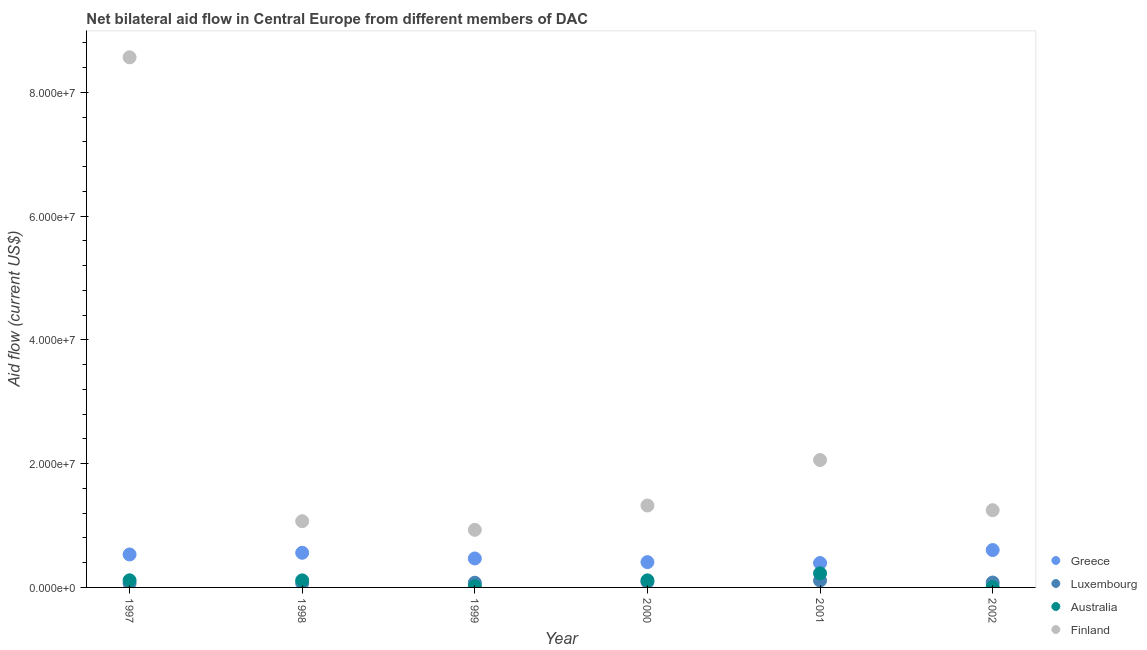How many different coloured dotlines are there?
Ensure brevity in your answer.  4. What is the amount of aid given by finland in 1999?
Make the answer very short. 9.31e+06. Across all years, what is the maximum amount of aid given by finland?
Make the answer very short. 8.57e+07. Across all years, what is the minimum amount of aid given by luxembourg?
Offer a very short reply. 6.50e+05. In which year was the amount of aid given by australia minimum?
Offer a terse response. 2002. What is the total amount of aid given by australia in the graph?
Your answer should be very brief. 5.96e+06. What is the difference between the amount of aid given by luxembourg in 2001 and that in 2002?
Your response must be concise. 3.20e+05. What is the difference between the amount of aid given by greece in 1998 and the amount of aid given by luxembourg in 2000?
Give a very brief answer. 4.72e+06. What is the average amount of aid given by australia per year?
Ensure brevity in your answer.  9.93e+05. In the year 1998, what is the difference between the amount of aid given by finland and amount of aid given by greece?
Give a very brief answer. 5.10e+06. In how many years, is the amount of aid given by australia greater than 24000000 US$?
Offer a terse response. 0. What is the ratio of the amount of aid given by greece in 2000 to that in 2001?
Ensure brevity in your answer.  1.04. What is the difference between the highest and the second highest amount of aid given by luxembourg?
Provide a succinct answer. 2.30e+05. What is the difference between the highest and the lowest amount of aid given by australia?
Offer a very short reply. 2.23e+06. In how many years, is the amount of aid given by greece greater than the average amount of aid given by greece taken over all years?
Ensure brevity in your answer.  3. Is it the case that in every year, the sum of the amount of aid given by luxembourg and amount of aid given by australia is greater than the sum of amount of aid given by greece and amount of aid given by finland?
Ensure brevity in your answer.  No. Does the amount of aid given by luxembourg monotonically increase over the years?
Offer a terse response. No. Is the amount of aid given by finland strictly greater than the amount of aid given by luxembourg over the years?
Provide a short and direct response. Yes. Is the amount of aid given by greece strictly less than the amount of aid given by luxembourg over the years?
Keep it short and to the point. No. How many dotlines are there?
Provide a short and direct response. 4. How many years are there in the graph?
Make the answer very short. 6. Are the values on the major ticks of Y-axis written in scientific E-notation?
Make the answer very short. Yes. Does the graph contain grids?
Provide a succinct answer. No. Where does the legend appear in the graph?
Offer a very short reply. Bottom right. How many legend labels are there?
Your answer should be very brief. 4. How are the legend labels stacked?
Make the answer very short. Vertical. What is the title of the graph?
Give a very brief answer. Net bilateral aid flow in Central Europe from different members of DAC. Does "Payroll services" appear as one of the legend labels in the graph?
Your answer should be very brief. No. What is the Aid flow (current US$) in Greece in 1997?
Offer a very short reply. 5.33e+06. What is the Aid flow (current US$) in Luxembourg in 1997?
Provide a short and direct response. 6.50e+05. What is the Aid flow (current US$) of Australia in 1997?
Provide a short and direct response. 1.15e+06. What is the Aid flow (current US$) of Finland in 1997?
Provide a short and direct response. 8.57e+07. What is the Aid flow (current US$) in Greece in 1998?
Ensure brevity in your answer.  5.60e+06. What is the Aid flow (current US$) of Luxembourg in 1998?
Keep it short and to the point. 6.90e+05. What is the Aid flow (current US$) in Australia in 1998?
Offer a terse response. 1.14e+06. What is the Aid flow (current US$) in Finland in 1998?
Ensure brevity in your answer.  1.07e+07. What is the Aid flow (current US$) in Greece in 1999?
Your answer should be very brief. 4.68e+06. What is the Aid flow (current US$) of Luxembourg in 1999?
Your answer should be very brief. 7.60e+05. What is the Aid flow (current US$) of Australia in 1999?
Give a very brief answer. 2.00e+05. What is the Aid flow (current US$) in Finland in 1999?
Your answer should be compact. 9.31e+06. What is the Aid flow (current US$) of Greece in 2000?
Keep it short and to the point. 4.09e+06. What is the Aid flow (current US$) of Luxembourg in 2000?
Your response must be concise. 8.80e+05. What is the Aid flow (current US$) of Australia in 2000?
Your answer should be compact. 1.14e+06. What is the Aid flow (current US$) in Finland in 2000?
Keep it short and to the point. 1.32e+07. What is the Aid flow (current US$) of Greece in 2001?
Give a very brief answer. 3.94e+06. What is the Aid flow (current US$) in Luxembourg in 2001?
Your response must be concise. 1.11e+06. What is the Aid flow (current US$) of Australia in 2001?
Make the answer very short. 2.28e+06. What is the Aid flow (current US$) of Finland in 2001?
Offer a terse response. 2.06e+07. What is the Aid flow (current US$) of Greece in 2002?
Your answer should be compact. 6.04e+06. What is the Aid flow (current US$) in Luxembourg in 2002?
Provide a succinct answer. 7.90e+05. What is the Aid flow (current US$) in Finland in 2002?
Provide a succinct answer. 1.25e+07. Across all years, what is the maximum Aid flow (current US$) in Greece?
Your answer should be compact. 6.04e+06. Across all years, what is the maximum Aid flow (current US$) in Luxembourg?
Your answer should be very brief. 1.11e+06. Across all years, what is the maximum Aid flow (current US$) in Australia?
Offer a very short reply. 2.28e+06. Across all years, what is the maximum Aid flow (current US$) of Finland?
Your answer should be compact. 8.57e+07. Across all years, what is the minimum Aid flow (current US$) in Greece?
Offer a very short reply. 3.94e+06. Across all years, what is the minimum Aid flow (current US$) of Luxembourg?
Offer a terse response. 6.50e+05. Across all years, what is the minimum Aid flow (current US$) in Finland?
Ensure brevity in your answer.  9.31e+06. What is the total Aid flow (current US$) of Greece in the graph?
Offer a very short reply. 2.97e+07. What is the total Aid flow (current US$) in Luxembourg in the graph?
Your response must be concise. 4.88e+06. What is the total Aid flow (current US$) in Australia in the graph?
Provide a succinct answer. 5.96e+06. What is the total Aid flow (current US$) of Finland in the graph?
Your answer should be compact. 1.52e+08. What is the difference between the Aid flow (current US$) in Greece in 1997 and that in 1998?
Offer a terse response. -2.70e+05. What is the difference between the Aid flow (current US$) of Finland in 1997 and that in 1998?
Ensure brevity in your answer.  7.50e+07. What is the difference between the Aid flow (current US$) of Greece in 1997 and that in 1999?
Your answer should be compact. 6.50e+05. What is the difference between the Aid flow (current US$) of Australia in 1997 and that in 1999?
Make the answer very short. 9.50e+05. What is the difference between the Aid flow (current US$) of Finland in 1997 and that in 1999?
Provide a succinct answer. 7.64e+07. What is the difference between the Aid flow (current US$) of Greece in 1997 and that in 2000?
Your answer should be compact. 1.24e+06. What is the difference between the Aid flow (current US$) in Luxembourg in 1997 and that in 2000?
Ensure brevity in your answer.  -2.30e+05. What is the difference between the Aid flow (current US$) of Australia in 1997 and that in 2000?
Provide a succinct answer. 10000. What is the difference between the Aid flow (current US$) in Finland in 1997 and that in 2000?
Offer a terse response. 7.24e+07. What is the difference between the Aid flow (current US$) of Greece in 1997 and that in 2001?
Keep it short and to the point. 1.39e+06. What is the difference between the Aid flow (current US$) of Luxembourg in 1997 and that in 2001?
Your answer should be compact. -4.60e+05. What is the difference between the Aid flow (current US$) of Australia in 1997 and that in 2001?
Give a very brief answer. -1.13e+06. What is the difference between the Aid flow (current US$) of Finland in 1997 and that in 2001?
Give a very brief answer. 6.51e+07. What is the difference between the Aid flow (current US$) of Greece in 1997 and that in 2002?
Give a very brief answer. -7.10e+05. What is the difference between the Aid flow (current US$) of Australia in 1997 and that in 2002?
Ensure brevity in your answer.  1.10e+06. What is the difference between the Aid flow (current US$) of Finland in 1997 and that in 2002?
Your answer should be compact. 7.32e+07. What is the difference between the Aid flow (current US$) of Greece in 1998 and that in 1999?
Your response must be concise. 9.20e+05. What is the difference between the Aid flow (current US$) of Luxembourg in 1998 and that in 1999?
Your answer should be very brief. -7.00e+04. What is the difference between the Aid flow (current US$) in Australia in 1998 and that in 1999?
Offer a terse response. 9.40e+05. What is the difference between the Aid flow (current US$) in Finland in 1998 and that in 1999?
Make the answer very short. 1.39e+06. What is the difference between the Aid flow (current US$) in Greece in 1998 and that in 2000?
Offer a very short reply. 1.51e+06. What is the difference between the Aid flow (current US$) in Luxembourg in 1998 and that in 2000?
Provide a short and direct response. -1.90e+05. What is the difference between the Aid flow (current US$) of Australia in 1998 and that in 2000?
Give a very brief answer. 0. What is the difference between the Aid flow (current US$) in Finland in 1998 and that in 2000?
Make the answer very short. -2.54e+06. What is the difference between the Aid flow (current US$) in Greece in 1998 and that in 2001?
Ensure brevity in your answer.  1.66e+06. What is the difference between the Aid flow (current US$) of Luxembourg in 1998 and that in 2001?
Offer a very short reply. -4.20e+05. What is the difference between the Aid flow (current US$) in Australia in 1998 and that in 2001?
Your answer should be very brief. -1.14e+06. What is the difference between the Aid flow (current US$) in Finland in 1998 and that in 2001?
Give a very brief answer. -9.89e+06. What is the difference between the Aid flow (current US$) of Greece in 1998 and that in 2002?
Provide a short and direct response. -4.40e+05. What is the difference between the Aid flow (current US$) in Australia in 1998 and that in 2002?
Keep it short and to the point. 1.09e+06. What is the difference between the Aid flow (current US$) of Finland in 1998 and that in 2002?
Your answer should be very brief. -1.78e+06. What is the difference between the Aid flow (current US$) in Greece in 1999 and that in 2000?
Offer a terse response. 5.90e+05. What is the difference between the Aid flow (current US$) in Australia in 1999 and that in 2000?
Your response must be concise. -9.40e+05. What is the difference between the Aid flow (current US$) in Finland in 1999 and that in 2000?
Offer a terse response. -3.93e+06. What is the difference between the Aid flow (current US$) in Greece in 1999 and that in 2001?
Give a very brief answer. 7.40e+05. What is the difference between the Aid flow (current US$) in Luxembourg in 1999 and that in 2001?
Your answer should be compact. -3.50e+05. What is the difference between the Aid flow (current US$) in Australia in 1999 and that in 2001?
Give a very brief answer. -2.08e+06. What is the difference between the Aid flow (current US$) of Finland in 1999 and that in 2001?
Give a very brief answer. -1.13e+07. What is the difference between the Aid flow (current US$) of Greece in 1999 and that in 2002?
Provide a short and direct response. -1.36e+06. What is the difference between the Aid flow (current US$) in Australia in 1999 and that in 2002?
Offer a very short reply. 1.50e+05. What is the difference between the Aid flow (current US$) in Finland in 1999 and that in 2002?
Your answer should be compact. -3.17e+06. What is the difference between the Aid flow (current US$) of Luxembourg in 2000 and that in 2001?
Give a very brief answer. -2.30e+05. What is the difference between the Aid flow (current US$) of Australia in 2000 and that in 2001?
Your answer should be very brief. -1.14e+06. What is the difference between the Aid flow (current US$) of Finland in 2000 and that in 2001?
Provide a succinct answer. -7.35e+06. What is the difference between the Aid flow (current US$) in Greece in 2000 and that in 2002?
Offer a terse response. -1.95e+06. What is the difference between the Aid flow (current US$) in Australia in 2000 and that in 2002?
Make the answer very short. 1.09e+06. What is the difference between the Aid flow (current US$) of Finland in 2000 and that in 2002?
Make the answer very short. 7.60e+05. What is the difference between the Aid flow (current US$) of Greece in 2001 and that in 2002?
Give a very brief answer. -2.10e+06. What is the difference between the Aid flow (current US$) in Luxembourg in 2001 and that in 2002?
Provide a succinct answer. 3.20e+05. What is the difference between the Aid flow (current US$) of Australia in 2001 and that in 2002?
Offer a very short reply. 2.23e+06. What is the difference between the Aid flow (current US$) of Finland in 2001 and that in 2002?
Provide a succinct answer. 8.11e+06. What is the difference between the Aid flow (current US$) in Greece in 1997 and the Aid flow (current US$) in Luxembourg in 1998?
Make the answer very short. 4.64e+06. What is the difference between the Aid flow (current US$) of Greece in 1997 and the Aid flow (current US$) of Australia in 1998?
Your answer should be compact. 4.19e+06. What is the difference between the Aid flow (current US$) of Greece in 1997 and the Aid flow (current US$) of Finland in 1998?
Make the answer very short. -5.37e+06. What is the difference between the Aid flow (current US$) of Luxembourg in 1997 and the Aid flow (current US$) of Australia in 1998?
Your answer should be very brief. -4.90e+05. What is the difference between the Aid flow (current US$) in Luxembourg in 1997 and the Aid flow (current US$) in Finland in 1998?
Make the answer very short. -1.00e+07. What is the difference between the Aid flow (current US$) of Australia in 1997 and the Aid flow (current US$) of Finland in 1998?
Ensure brevity in your answer.  -9.55e+06. What is the difference between the Aid flow (current US$) of Greece in 1997 and the Aid flow (current US$) of Luxembourg in 1999?
Make the answer very short. 4.57e+06. What is the difference between the Aid flow (current US$) in Greece in 1997 and the Aid flow (current US$) in Australia in 1999?
Ensure brevity in your answer.  5.13e+06. What is the difference between the Aid flow (current US$) of Greece in 1997 and the Aid flow (current US$) of Finland in 1999?
Keep it short and to the point. -3.98e+06. What is the difference between the Aid flow (current US$) in Luxembourg in 1997 and the Aid flow (current US$) in Finland in 1999?
Offer a terse response. -8.66e+06. What is the difference between the Aid flow (current US$) of Australia in 1997 and the Aid flow (current US$) of Finland in 1999?
Give a very brief answer. -8.16e+06. What is the difference between the Aid flow (current US$) of Greece in 1997 and the Aid flow (current US$) of Luxembourg in 2000?
Give a very brief answer. 4.45e+06. What is the difference between the Aid flow (current US$) of Greece in 1997 and the Aid flow (current US$) of Australia in 2000?
Your answer should be compact. 4.19e+06. What is the difference between the Aid flow (current US$) of Greece in 1997 and the Aid flow (current US$) of Finland in 2000?
Your answer should be compact. -7.91e+06. What is the difference between the Aid flow (current US$) of Luxembourg in 1997 and the Aid flow (current US$) of Australia in 2000?
Offer a very short reply. -4.90e+05. What is the difference between the Aid flow (current US$) of Luxembourg in 1997 and the Aid flow (current US$) of Finland in 2000?
Ensure brevity in your answer.  -1.26e+07. What is the difference between the Aid flow (current US$) of Australia in 1997 and the Aid flow (current US$) of Finland in 2000?
Provide a short and direct response. -1.21e+07. What is the difference between the Aid flow (current US$) in Greece in 1997 and the Aid flow (current US$) in Luxembourg in 2001?
Provide a succinct answer. 4.22e+06. What is the difference between the Aid flow (current US$) in Greece in 1997 and the Aid flow (current US$) in Australia in 2001?
Your response must be concise. 3.05e+06. What is the difference between the Aid flow (current US$) of Greece in 1997 and the Aid flow (current US$) of Finland in 2001?
Your answer should be very brief. -1.53e+07. What is the difference between the Aid flow (current US$) of Luxembourg in 1997 and the Aid flow (current US$) of Australia in 2001?
Provide a succinct answer. -1.63e+06. What is the difference between the Aid flow (current US$) in Luxembourg in 1997 and the Aid flow (current US$) in Finland in 2001?
Offer a terse response. -1.99e+07. What is the difference between the Aid flow (current US$) of Australia in 1997 and the Aid flow (current US$) of Finland in 2001?
Ensure brevity in your answer.  -1.94e+07. What is the difference between the Aid flow (current US$) of Greece in 1997 and the Aid flow (current US$) of Luxembourg in 2002?
Provide a short and direct response. 4.54e+06. What is the difference between the Aid flow (current US$) of Greece in 1997 and the Aid flow (current US$) of Australia in 2002?
Your answer should be compact. 5.28e+06. What is the difference between the Aid flow (current US$) in Greece in 1997 and the Aid flow (current US$) in Finland in 2002?
Your answer should be compact. -7.15e+06. What is the difference between the Aid flow (current US$) in Luxembourg in 1997 and the Aid flow (current US$) in Finland in 2002?
Ensure brevity in your answer.  -1.18e+07. What is the difference between the Aid flow (current US$) in Australia in 1997 and the Aid flow (current US$) in Finland in 2002?
Ensure brevity in your answer.  -1.13e+07. What is the difference between the Aid flow (current US$) of Greece in 1998 and the Aid flow (current US$) of Luxembourg in 1999?
Keep it short and to the point. 4.84e+06. What is the difference between the Aid flow (current US$) of Greece in 1998 and the Aid flow (current US$) of Australia in 1999?
Offer a very short reply. 5.40e+06. What is the difference between the Aid flow (current US$) of Greece in 1998 and the Aid flow (current US$) of Finland in 1999?
Provide a short and direct response. -3.71e+06. What is the difference between the Aid flow (current US$) of Luxembourg in 1998 and the Aid flow (current US$) of Australia in 1999?
Offer a very short reply. 4.90e+05. What is the difference between the Aid flow (current US$) of Luxembourg in 1998 and the Aid flow (current US$) of Finland in 1999?
Offer a terse response. -8.62e+06. What is the difference between the Aid flow (current US$) in Australia in 1998 and the Aid flow (current US$) in Finland in 1999?
Provide a succinct answer. -8.17e+06. What is the difference between the Aid flow (current US$) of Greece in 1998 and the Aid flow (current US$) of Luxembourg in 2000?
Provide a succinct answer. 4.72e+06. What is the difference between the Aid flow (current US$) of Greece in 1998 and the Aid flow (current US$) of Australia in 2000?
Offer a very short reply. 4.46e+06. What is the difference between the Aid flow (current US$) in Greece in 1998 and the Aid flow (current US$) in Finland in 2000?
Give a very brief answer. -7.64e+06. What is the difference between the Aid flow (current US$) of Luxembourg in 1998 and the Aid flow (current US$) of Australia in 2000?
Keep it short and to the point. -4.50e+05. What is the difference between the Aid flow (current US$) of Luxembourg in 1998 and the Aid flow (current US$) of Finland in 2000?
Your response must be concise. -1.26e+07. What is the difference between the Aid flow (current US$) in Australia in 1998 and the Aid flow (current US$) in Finland in 2000?
Provide a short and direct response. -1.21e+07. What is the difference between the Aid flow (current US$) in Greece in 1998 and the Aid flow (current US$) in Luxembourg in 2001?
Your answer should be compact. 4.49e+06. What is the difference between the Aid flow (current US$) of Greece in 1998 and the Aid flow (current US$) of Australia in 2001?
Keep it short and to the point. 3.32e+06. What is the difference between the Aid flow (current US$) of Greece in 1998 and the Aid flow (current US$) of Finland in 2001?
Your answer should be very brief. -1.50e+07. What is the difference between the Aid flow (current US$) in Luxembourg in 1998 and the Aid flow (current US$) in Australia in 2001?
Keep it short and to the point. -1.59e+06. What is the difference between the Aid flow (current US$) in Luxembourg in 1998 and the Aid flow (current US$) in Finland in 2001?
Provide a succinct answer. -1.99e+07. What is the difference between the Aid flow (current US$) in Australia in 1998 and the Aid flow (current US$) in Finland in 2001?
Ensure brevity in your answer.  -1.94e+07. What is the difference between the Aid flow (current US$) of Greece in 1998 and the Aid flow (current US$) of Luxembourg in 2002?
Ensure brevity in your answer.  4.81e+06. What is the difference between the Aid flow (current US$) in Greece in 1998 and the Aid flow (current US$) in Australia in 2002?
Provide a short and direct response. 5.55e+06. What is the difference between the Aid flow (current US$) of Greece in 1998 and the Aid flow (current US$) of Finland in 2002?
Your response must be concise. -6.88e+06. What is the difference between the Aid flow (current US$) in Luxembourg in 1998 and the Aid flow (current US$) in Australia in 2002?
Keep it short and to the point. 6.40e+05. What is the difference between the Aid flow (current US$) in Luxembourg in 1998 and the Aid flow (current US$) in Finland in 2002?
Make the answer very short. -1.18e+07. What is the difference between the Aid flow (current US$) of Australia in 1998 and the Aid flow (current US$) of Finland in 2002?
Offer a very short reply. -1.13e+07. What is the difference between the Aid flow (current US$) in Greece in 1999 and the Aid flow (current US$) in Luxembourg in 2000?
Provide a succinct answer. 3.80e+06. What is the difference between the Aid flow (current US$) in Greece in 1999 and the Aid flow (current US$) in Australia in 2000?
Provide a short and direct response. 3.54e+06. What is the difference between the Aid flow (current US$) in Greece in 1999 and the Aid flow (current US$) in Finland in 2000?
Your answer should be compact. -8.56e+06. What is the difference between the Aid flow (current US$) in Luxembourg in 1999 and the Aid flow (current US$) in Australia in 2000?
Your answer should be very brief. -3.80e+05. What is the difference between the Aid flow (current US$) in Luxembourg in 1999 and the Aid flow (current US$) in Finland in 2000?
Your answer should be very brief. -1.25e+07. What is the difference between the Aid flow (current US$) of Australia in 1999 and the Aid flow (current US$) of Finland in 2000?
Offer a very short reply. -1.30e+07. What is the difference between the Aid flow (current US$) in Greece in 1999 and the Aid flow (current US$) in Luxembourg in 2001?
Ensure brevity in your answer.  3.57e+06. What is the difference between the Aid flow (current US$) in Greece in 1999 and the Aid flow (current US$) in Australia in 2001?
Provide a succinct answer. 2.40e+06. What is the difference between the Aid flow (current US$) of Greece in 1999 and the Aid flow (current US$) of Finland in 2001?
Your answer should be compact. -1.59e+07. What is the difference between the Aid flow (current US$) in Luxembourg in 1999 and the Aid flow (current US$) in Australia in 2001?
Your response must be concise. -1.52e+06. What is the difference between the Aid flow (current US$) of Luxembourg in 1999 and the Aid flow (current US$) of Finland in 2001?
Ensure brevity in your answer.  -1.98e+07. What is the difference between the Aid flow (current US$) in Australia in 1999 and the Aid flow (current US$) in Finland in 2001?
Your answer should be very brief. -2.04e+07. What is the difference between the Aid flow (current US$) in Greece in 1999 and the Aid flow (current US$) in Luxembourg in 2002?
Your answer should be compact. 3.89e+06. What is the difference between the Aid flow (current US$) in Greece in 1999 and the Aid flow (current US$) in Australia in 2002?
Offer a terse response. 4.63e+06. What is the difference between the Aid flow (current US$) of Greece in 1999 and the Aid flow (current US$) of Finland in 2002?
Ensure brevity in your answer.  -7.80e+06. What is the difference between the Aid flow (current US$) in Luxembourg in 1999 and the Aid flow (current US$) in Australia in 2002?
Provide a short and direct response. 7.10e+05. What is the difference between the Aid flow (current US$) of Luxembourg in 1999 and the Aid flow (current US$) of Finland in 2002?
Your answer should be very brief. -1.17e+07. What is the difference between the Aid flow (current US$) of Australia in 1999 and the Aid flow (current US$) of Finland in 2002?
Provide a succinct answer. -1.23e+07. What is the difference between the Aid flow (current US$) in Greece in 2000 and the Aid flow (current US$) in Luxembourg in 2001?
Provide a succinct answer. 2.98e+06. What is the difference between the Aid flow (current US$) of Greece in 2000 and the Aid flow (current US$) of Australia in 2001?
Your response must be concise. 1.81e+06. What is the difference between the Aid flow (current US$) in Greece in 2000 and the Aid flow (current US$) in Finland in 2001?
Your answer should be very brief. -1.65e+07. What is the difference between the Aid flow (current US$) in Luxembourg in 2000 and the Aid flow (current US$) in Australia in 2001?
Make the answer very short. -1.40e+06. What is the difference between the Aid flow (current US$) of Luxembourg in 2000 and the Aid flow (current US$) of Finland in 2001?
Provide a short and direct response. -1.97e+07. What is the difference between the Aid flow (current US$) of Australia in 2000 and the Aid flow (current US$) of Finland in 2001?
Your response must be concise. -1.94e+07. What is the difference between the Aid flow (current US$) in Greece in 2000 and the Aid flow (current US$) in Luxembourg in 2002?
Your answer should be compact. 3.30e+06. What is the difference between the Aid flow (current US$) in Greece in 2000 and the Aid flow (current US$) in Australia in 2002?
Provide a succinct answer. 4.04e+06. What is the difference between the Aid flow (current US$) of Greece in 2000 and the Aid flow (current US$) of Finland in 2002?
Make the answer very short. -8.39e+06. What is the difference between the Aid flow (current US$) in Luxembourg in 2000 and the Aid flow (current US$) in Australia in 2002?
Your answer should be compact. 8.30e+05. What is the difference between the Aid flow (current US$) in Luxembourg in 2000 and the Aid flow (current US$) in Finland in 2002?
Make the answer very short. -1.16e+07. What is the difference between the Aid flow (current US$) in Australia in 2000 and the Aid flow (current US$) in Finland in 2002?
Keep it short and to the point. -1.13e+07. What is the difference between the Aid flow (current US$) of Greece in 2001 and the Aid flow (current US$) of Luxembourg in 2002?
Offer a terse response. 3.15e+06. What is the difference between the Aid flow (current US$) in Greece in 2001 and the Aid flow (current US$) in Australia in 2002?
Your response must be concise. 3.89e+06. What is the difference between the Aid flow (current US$) in Greece in 2001 and the Aid flow (current US$) in Finland in 2002?
Offer a terse response. -8.54e+06. What is the difference between the Aid flow (current US$) of Luxembourg in 2001 and the Aid flow (current US$) of Australia in 2002?
Provide a succinct answer. 1.06e+06. What is the difference between the Aid flow (current US$) in Luxembourg in 2001 and the Aid flow (current US$) in Finland in 2002?
Provide a succinct answer. -1.14e+07. What is the difference between the Aid flow (current US$) of Australia in 2001 and the Aid flow (current US$) of Finland in 2002?
Your answer should be very brief. -1.02e+07. What is the average Aid flow (current US$) of Greece per year?
Make the answer very short. 4.95e+06. What is the average Aid flow (current US$) of Luxembourg per year?
Your response must be concise. 8.13e+05. What is the average Aid flow (current US$) in Australia per year?
Keep it short and to the point. 9.93e+05. What is the average Aid flow (current US$) in Finland per year?
Your answer should be compact. 2.53e+07. In the year 1997, what is the difference between the Aid flow (current US$) of Greece and Aid flow (current US$) of Luxembourg?
Make the answer very short. 4.68e+06. In the year 1997, what is the difference between the Aid flow (current US$) of Greece and Aid flow (current US$) of Australia?
Your response must be concise. 4.18e+06. In the year 1997, what is the difference between the Aid flow (current US$) in Greece and Aid flow (current US$) in Finland?
Keep it short and to the point. -8.03e+07. In the year 1997, what is the difference between the Aid flow (current US$) in Luxembourg and Aid flow (current US$) in Australia?
Ensure brevity in your answer.  -5.00e+05. In the year 1997, what is the difference between the Aid flow (current US$) in Luxembourg and Aid flow (current US$) in Finland?
Offer a very short reply. -8.50e+07. In the year 1997, what is the difference between the Aid flow (current US$) in Australia and Aid flow (current US$) in Finland?
Offer a terse response. -8.45e+07. In the year 1998, what is the difference between the Aid flow (current US$) of Greece and Aid flow (current US$) of Luxembourg?
Your answer should be very brief. 4.91e+06. In the year 1998, what is the difference between the Aid flow (current US$) in Greece and Aid flow (current US$) in Australia?
Provide a succinct answer. 4.46e+06. In the year 1998, what is the difference between the Aid flow (current US$) in Greece and Aid flow (current US$) in Finland?
Ensure brevity in your answer.  -5.10e+06. In the year 1998, what is the difference between the Aid flow (current US$) of Luxembourg and Aid flow (current US$) of Australia?
Make the answer very short. -4.50e+05. In the year 1998, what is the difference between the Aid flow (current US$) of Luxembourg and Aid flow (current US$) of Finland?
Offer a very short reply. -1.00e+07. In the year 1998, what is the difference between the Aid flow (current US$) in Australia and Aid flow (current US$) in Finland?
Your answer should be compact. -9.56e+06. In the year 1999, what is the difference between the Aid flow (current US$) of Greece and Aid flow (current US$) of Luxembourg?
Make the answer very short. 3.92e+06. In the year 1999, what is the difference between the Aid flow (current US$) in Greece and Aid flow (current US$) in Australia?
Provide a succinct answer. 4.48e+06. In the year 1999, what is the difference between the Aid flow (current US$) in Greece and Aid flow (current US$) in Finland?
Provide a succinct answer. -4.63e+06. In the year 1999, what is the difference between the Aid flow (current US$) in Luxembourg and Aid flow (current US$) in Australia?
Give a very brief answer. 5.60e+05. In the year 1999, what is the difference between the Aid flow (current US$) in Luxembourg and Aid flow (current US$) in Finland?
Ensure brevity in your answer.  -8.55e+06. In the year 1999, what is the difference between the Aid flow (current US$) in Australia and Aid flow (current US$) in Finland?
Offer a terse response. -9.11e+06. In the year 2000, what is the difference between the Aid flow (current US$) in Greece and Aid flow (current US$) in Luxembourg?
Offer a very short reply. 3.21e+06. In the year 2000, what is the difference between the Aid flow (current US$) in Greece and Aid flow (current US$) in Australia?
Provide a short and direct response. 2.95e+06. In the year 2000, what is the difference between the Aid flow (current US$) in Greece and Aid flow (current US$) in Finland?
Provide a short and direct response. -9.15e+06. In the year 2000, what is the difference between the Aid flow (current US$) in Luxembourg and Aid flow (current US$) in Finland?
Your answer should be very brief. -1.24e+07. In the year 2000, what is the difference between the Aid flow (current US$) in Australia and Aid flow (current US$) in Finland?
Your response must be concise. -1.21e+07. In the year 2001, what is the difference between the Aid flow (current US$) of Greece and Aid flow (current US$) of Luxembourg?
Keep it short and to the point. 2.83e+06. In the year 2001, what is the difference between the Aid flow (current US$) in Greece and Aid flow (current US$) in Australia?
Your response must be concise. 1.66e+06. In the year 2001, what is the difference between the Aid flow (current US$) in Greece and Aid flow (current US$) in Finland?
Provide a succinct answer. -1.66e+07. In the year 2001, what is the difference between the Aid flow (current US$) of Luxembourg and Aid flow (current US$) of Australia?
Keep it short and to the point. -1.17e+06. In the year 2001, what is the difference between the Aid flow (current US$) of Luxembourg and Aid flow (current US$) of Finland?
Your answer should be very brief. -1.95e+07. In the year 2001, what is the difference between the Aid flow (current US$) of Australia and Aid flow (current US$) of Finland?
Your answer should be compact. -1.83e+07. In the year 2002, what is the difference between the Aid flow (current US$) in Greece and Aid flow (current US$) in Luxembourg?
Provide a short and direct response. 5.25e+06. In the year 2002, what is the difference between the Aid flow (current US$) of Greece and Aid flow (current US$) of Australia?
Keep it short and to the point. 5.99e+06. In the year 2002, what is the difference between the Aid flow (current US$) of Greece and Aid flow (current US$) of Finland?
Provide a short and direct response. -6.44e+06. In the year 2002, what is the difference between the Aid flow (current US$) of Luxembourg and Aid flow (current US$) of Australia?
Provide a succinct answer. 7.40e+05. In the year 2002, what is the difference between the Aid flow (current US$) of Luxembourg and Aid flow (current US$) of Finland?
Your answer should be very brief. -1.17e+07. In the year 2002, what is the difference between the Aid flow (current US$) in Australia and Aid flow (current US$) in Finland?
Provide a short and direct response. -1.24e+07. What is the ratio of the Aid flow (current US$) of Greece in 1997 to that in 1998?
Your answer should be very brief. 0.95. What is the ratio of the Aid flow (current US$) of Luxembourg in 1997 to that in 1998?
Provide a succinct answer. 0.94. What is the ratio of the Aid flow (current US$) in Australia in 1997 to that in 1998?
Keep it short and to the point. 1.01. What is the ratio of the Aid flow (current US$) of Finland in 1997 to that in 1998?
Make the answer very short. 8.01. What is the ratio of the Aid flow (current US$) of Greece in 1997 to that in 1999?
Give a very brief answer. 1.14. What is the ratio of the Aid flow (current US$) in Luxembourg in 1997 to that in 1999?
Provide a succinct answer. 0.86. What is the ratio of the Aid flow (current US$) in Australia in 1997 to that in 1999?
Your response must be concise. 5.75. What is the ratio of the Aid flow (current US$) in Finland in 1997 to that in 1999?
Your answer should be compact. 9.2. What is the ratio of the Aid flow (current US$) of Greece in 1997 to that in 2000?
Provide a succinct answer. 1.3. What is the ratio of the Aid flow (current US$) in Luxembourg in 1997 to that in 2000?
Make the answer very short. 0.74. What is the ratio of the Aid flow (current US$) of Australia in 1997 to that in 2000?
Your answer should be very brief. 1.01. What is the ratio of the Aid flow (current US$) of Finland in 1997 to that in 2000?
Your answer should be compact. 6.47. What is the ratio of the Aid flow (current US$) in Greece in 1997 to that in 2001?
Give a very brief answer. 1.35. What is the ratio of the Aid flow (current US$) of Luxembourg in 1997 to that in 2001?
Offer a terse response. 0.59. What is the ratio of the Aid flow (current US$) in Australia in 1997 to that in 2001?
Your response must be concise. 0.5. What is the ratio of the Aid flow (current US$) of Finland in 1997 to that in 2001?
Provide a short and direct response. 4.16. What is the ratio of the Aid flow (current US$) of Greece in 1997 to that in 2002?
Offer a terse response. 0.88. What is the ratio of the Aid flow (current US$) of Luxembourg in 1997 to that in 2002?
Make the answer very short. 0.82. What is the ratio of the Aid flow (current US$) in Finland in 1997 to that in 2002?
Your response must be concise. 6.86. What is the ratio of the Aid flow (current US$) in Greece in 1998 to that in 1999?
Ensure brevity in your answer.  1.2. What is the ratio of the Aid flow (current US$) of Luxembourg in 1998 to that in 1999?
Your answer should be very brief. 0.91. What is the ratio of the Aid flow (current US$) of Australia in 1998 to that in 1999?
Your answer should be compact. 5.7. What is the ratio of the Aid flow (current US$) of Finland in 1998 to that in 1999?
Give a very brief answer. 1.15. What is the ratio of the Aid flow (current US$) in Greece in 1998 to that in 2000?
Your answer should be very brief. 1.37. What is the ratio of the Aid flow (current US$) of Luxembourg in 1998 to that in 2000?
Give a very brief answer. 0.78. What is the ratio of the Aid flow (current US$) in Australia in 1998 to that in 2000?
Offer a terse response. 1. What is the ratio of the Aid flow (current US$) in Finland in 1998 to that in 2000?
Your answer should be very brief. 0.81. What is the ratio of the Aid flow (current US$) in Greece in 1998 to that in 2001?
Keep it short and to the point. 1.42. What is the ratio of the Aid flow (current US$) in Luxembourg in 1998 to that in 2001?
Your answer should be compact. 0.62. What is the ratio of the Aid flow (current US$) in Finland in 1998 to that in 2001?
Keep it short and to the point. 0.52. What is the ratio of the Aid flow (current US$) in Greece in 1998 to that in 2002?
Offer a terse response. 0.93. What is the ratio of the Aid flow (current US$) in Luxembourg in 1998 to that in 2002?
Give a very brief answer. 0.87. What is the ratio of the Aid flow (current US$) of Australia in 1998 to that in 2002?
Offer a very short reply. 22.8. What is the ratio of the Aid flow (current US$) in Finland in 1998 to that in 2002?
Keep it short and to the point. 0.86. What is the ratio of the Aid flow (current US$) of Greece in 1999 to that in 2000?
Provide a succinct answer. 1.14. What is the ratio of the Aid flow (current US$) of Luxembourg in 1999 to that in 2000?
Your answer should be compact. 0.86. What is the ratio of the Aid flow (current US$) of Australia in 1999 to that in 2000?
Keep it short and to the point. 0.18. What is the ratio of the Aid flow (current US$) in Finland in 1999 to that in 2000?
Provide a succinct answer. 0.7. What is the ratio of the Aid flow (current US$) in Greece in 1999 to that in 2001?
Offer a very short reply. 1.19. What is the ratio of the Aid flow (current US$) of Luxembourg in 1999 to that in 2001?
Keep it short and to the point. 0.68. What is the ratio of the Aid flow (current US$) in Australia in 1999 to that in 2001?
Your answer should be very brief. 0.09. What is the ratio of the Aid flow (current US$) of Finland in 1999 to that in 2001?
Offer a very short reply. 0.45. What is the ratio of the Aid flow (current US$) of Greece in 1999 to that in 2002?
Provide a short and direct response. 0.77. What is the ratio of the Aid flow (current US$) in Finland in 1999 to that in 2002?
Provide a succinct answer. 0.75. What is the ratio of the Aid flow (current US$) in Greece in 2000 to that in 2001?
Keep it short and to the point. 1.04. What is the ratio of the Aid flow (current US$) of Luxembourg in 2000 to that in 2001?
Your response must be concise. 0.79. What is the ratio of the Aid flow (current US$) in Australia in 2000 to that in 2001?
Your answer should be compact. 0.5. What is the ratio of the Aid flow (current US$) in Finland in 2000 to that in 2001?
Give a very brief answer. 0.64. What is the ratio of the Aid flow (current US$) in Greece in 2000 to that in 2002?
Offer a terse response. 0.68. What is the ratio of the Aid flow (current US$) of Luxembourg in 2000 to that in 2002?
Make the answer very short. 1.11. What is the ratio of the Aid flow (current US$) in Australia in 2000 to that in 2002?
Make the answer very short. 22.8. What is the ratio of the Aid flow (current US$) in Finland in 2000 to that in 2002?
Keep it short and to the point. 1.06. What is the ratio of the Aid flow (current US$) of Greece in 2001 to that in 2002?
Your answer should be very brief. 0.65. What is the ratio of the Aid flow (current US$) in Luxembourg in 2001 to that in 2002?
Your response must be concise. 1.41. What is the ratio of the Aid flow (current US$) of Australia in 2001 to that in 2002?
Your answer should be compact. 45.6. What is the ratio of the Aid flow (current US$) in Finland in 2001 to that in 2002?
Give a very brief answer. 1.65. What is the difference between the highest and the second highest Aid flow (current US$) of Greece?
Provide a succinct answer. 4.40e+05. What is the difference between the highest and the second highest Aid flow (current US$) of Australia?
Your answer should be compact. 1.13e+06. What is the difference between the highest and the second highest Aid flow (current US$) of Finland?
Give a very brief answer. 6.51e+07. What is the difference between the highest and the lowest Aid flow (current US$) of Greece?
Provide a succinct answer. 2.10e+06. What is the difference between the highest and the lowest Aid flow (current US$) of Australia?
Keep it short and to the point. 2.23e+06. What is the difference between the highest and the lowest Aid flow (current US$) of Finland?
Provide a succinct answer. 7.64e+07. 